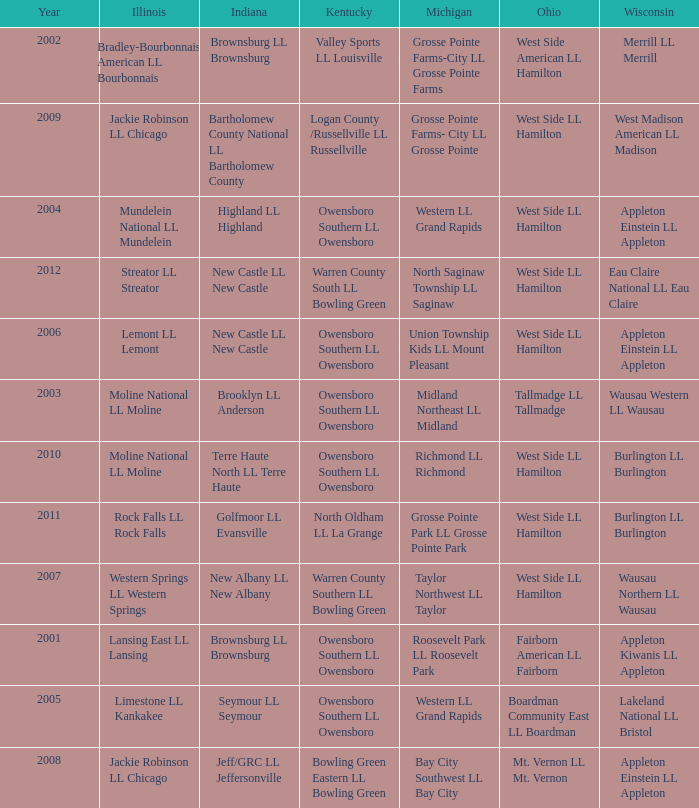What was the little league team from Michigan when the little league team from Indiana was Terre Haute North LL Terre Haute?  Richmond LL Richmond. 